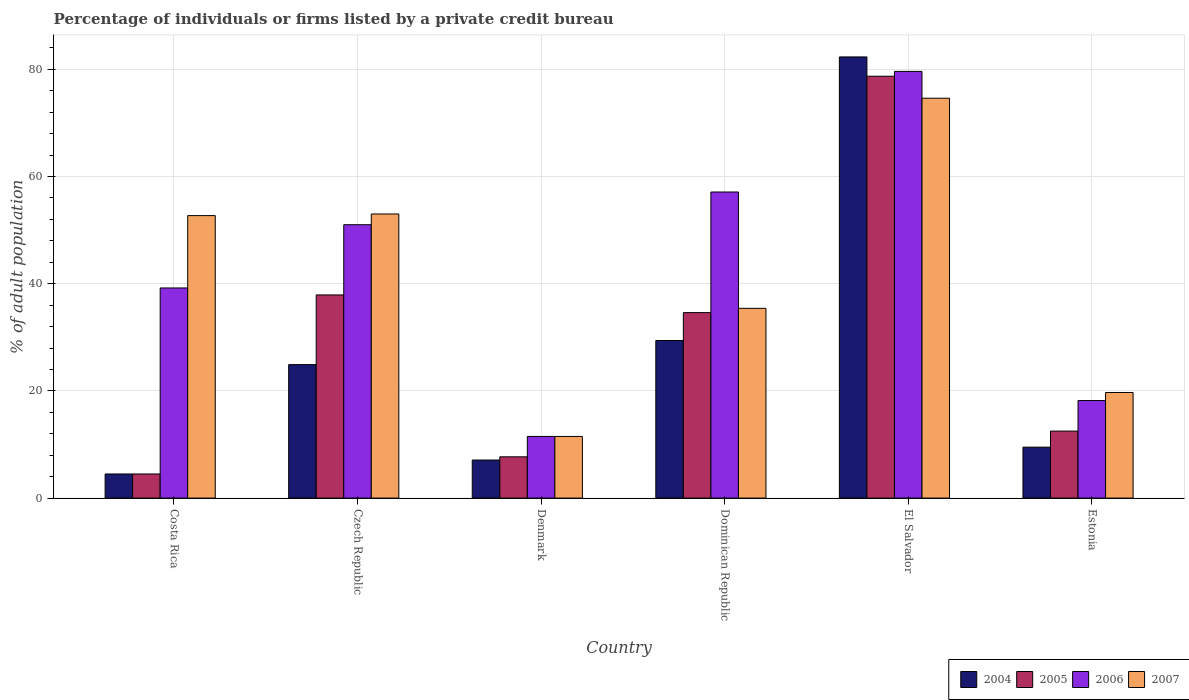How many groups of bars are there?
Offer a terse response. 6. Are the number of bars per tick equal to the number of legend labels?
Your answer should be very brief. Yes. How many bars are there on the 6th tick from the left?
Your response must be concise. 4. How many bars are there on the 6th tick from the right?
Your response must be concise. 4. What is the label of the 5th group of bars from the left?
Provide a short and direct response. El Salvador. In how many cases, is the number of bars for a given country not equal to the number of legend labels?
Make the answer very short. 0. Across all countries, what is the maximum percentage of population listed by a private credit bureau in 2004?
Provide a succinct answer. 82.3. Across all countries, what is the minimum percentage of population listed by a private credit bureau in 2005?
Your response must be concise. 4.5. In which country was the percentage of population listed by a private credit bureau in 2006 maximum?
Your answer should be very brief. El Salvador. In which country was the percentage of population listed by a private credit bureau in 2004 minimum?
Provide a short and direct response. Costa Rica. What is the total percentage of population listed by a private credit bureau in 2007 in the graph?
Make the answer very short. 246.9. What is the difference between the percentage of population listed by a private credit bureau in 2007 in Costa Rica and that in Denmark?
Give a very brief answer. 41.2. What is the difference between the percentage of population listed by a private credit bureau in 2004 in Estonia and the percentage of population listed by a private credit bureau in 2005 in Dominican Republic?
Your response must be concise. -25.1. What is the average percentage of population listed by a private credit bureau in 2006 per country?
Provide a short and direct response. 42.77. What is the difference between the percentage of population listed by a private credit bureau of/in 2007 and percentage of population listed by a private credit bureau of/in 2006 in Dominican Republic?
Offer a terse response. -21.7. In how many countries, is the percentage of population listed by a private credit bureau in 2004 greater than 32 %?
Your answer should be very brief. 1. What is the ratio of the percentage of population listed by a private credit bureau in 2007 in Czech Republic to that in Estonia?
Provide a short and direct response. 2.69. Is the percentage of population listed by a private credit bureau in 2004 in Costa Rica less than that in Dominican Republic?
Your answer should be very brief. Yes. Is the difference between the percentage of population listed by a private credit bureau in 2007 in Costa Rica and Denmark greater than the difference between the percentage of population listed by a private credit bureau in 2006 in Costa Rica and Denmark?
Offer a terse response. Yes. What is the difference between the highest and the second highest percentage of population listed by a private credit bureau in 2007?
Ensure brevity in your answer.  21.9. What is the difference between the highest and the lowest percentage of population listed by a private credit bureau in 2006?
Keep it short and to the point. 68.1. Is the sum of the percentage of population listed by a private credit bureau in 2005 in Costa Rica and El Salvador greater than the maximum percentage of population listed by a private credit bureau in 2004 across all countries?
Make the answer very short. Yes. What does the 3rd bar from the right in Dominican Republic represents?
Provide a succinct answer. 2005. Are all the bars in the graph horizontal?
Your answer should be compact. No. How many countries are there in the graph?
Give a very brief answer. 6. What is the difference between two consecutive major ticks on the Y-axis?
Your response must be concise. 20. Are the values on the major ticks of Y-axis written in scientific E-notation?
Your answer should be compact. No. What is the title of the graph?
Give a very brief answer. Percentage of individuals or firms listed by a private credit bureau. Does "1995" appear as one of the legend labels in the graph?
Your answer should be very brief. No. What is the label or title of the Y-axis?
Your answer should be very brief. % of adult population. What is the % of adult population in 2005 in Costa Rica?
Offer a very short reply. 4.5. What is the % of adult population of 2006 in Costa Rica?
Your answer should be compact. 39.2. What is the % of adult population of 2007 in Costa Rica?
Your answer should be compact. 52.7. What is the % of adult population in 2004 in Czech Republic?
Keep it short and to the point. 24.9. What is the % of adult population of 2005 in Czech Republic?
Ensure brevity in your answer.  37.9. What is the % of adult population in 2006 in Czech Republic?
Keep it short and to the point. 51. What is the % of adult population in 2007 in Czech Republic?
Offer a terse response. 53. What is the % of adult population in 2005 in Denmark?
Offer a very short reply. 7.7. What is the % of adult population in 2006 in Denmark?
Your response must be concise. 11.5. What is the % of adult population in 2004 in Dominican Republic?
Make the answer very short. 29.4. What is the % of adult population in 2005 in Dominican Republic?
Provide a short and direct response. 34.6. What is the % of adult population of 2006 in Dominican Republic?
Your answer should be compact. 57.1. What is the % of adult population of 2007 in Dominican Republic?
Ensure brevity in your answer.  35.4. What is the % of adult population of 2004 in El Salvador?
Offer a very short reply. 82.3. What is the % of adult population of 2005 in El Salvador?
Give a very brief answer. 78.7. What is the % of adult population in 2006 in El Salvador?
Provide a short and direct response. 79.6. What is the % of adult population of 2007 in El Salvador?
Make the answer very short. 74.6. What is the % of adult population in 2005 in Estonia?
Provide a short and direct response. 12.5. What is the % of adult population in 2007 in Estonia?
Offer a very short reply. 19.7. Across all countries, what is the maximum % of adult population in 2004?
Give a very brief answer. 82.3. Across all countries, what is the maximum % of adult population in 2005?
Ensure brevity in your answer.  78.7. Across all countries, what is the maximum % of adult population of 2006?
Your answer should be compact. 79.6. Across all countries, what is the maximum % of adult population of 2007?
Give a very brief answer. 74.6. Across all countries, what is the minimum % of adult population in 2004?
Keep it short and to the point. 4.5. Across all countries, what is the minimum % of adult population of 2005?
Provide a succinct answer. 4.5. Across all countries, what is the minimum % of adult population of 2006?
Your response must be concise. 11.5. Across all countries, what is the minimum % of adult population in 2007?
Offer a terse response. 11.5. What is the total % of adult population of 2004 in the graph?
Your answer should be very brief. 157.7. What is the total % of adult population of 2005 in the graph?
Keep it short and to the point. 175.9. What is the total % of adult population of 2006 in the graph?
Keep it short and to the point. 256.6. What is the total % of adult population in 2007 in the graph?
Make the answer very short. 246.9. What is the difference between the % of adult population in 2004 in Costa Rica and that in Czech Republic?
Provide a succinct answer. -20.4. What is the difference between the % of adult population of 2005 in Costa Rica and that in Czech Republic?
Your answer should be compact. -33.4. What is the difference between the % of adult population of 2004 in Costa Rica and that in Denmark?
Keep it short and to the point. -2.6. What is the difference between the % of adult population of 2006 in Costa Rica and that in Denmark?
Offer a very short reply. 27.7. What is the difference between the % of adult population in 2007 in Costa Rica and that in Denmark?
Keep it short and to the point. 41.2. What is the difference between the % of adult population in 2004 in Costa Rica and that in Dominican Republic?
Give a very brief answer. -24.9. What is the difference between the % of adult population in 2005 in Costa Rica and that in Dominican Republic?
Keep it short and to the point. -30.1. What is the difference between the % of adult population of 2006 in Costa Rica and that in Dominican Republic?
Your answer should be very brief. -17.9. What is the difference between the % of adult population of 2004 in Costa Rica and that in El Salvador?
Provide a succinct answer. -77.8. What is the difference between the % of adult population in 2005 in Costa Rica and that in El Salvador?
Your answer should be compact. -74.2. What is the difference between the % of adult population in 2006 in Costa Rica and that in El Salvador?
Keep it short and to the point. -40.4. What is the difference between the % of adult population of 2007 in Costa Rica and that in El Salvador?
Your response must be concise. -21.9. What is the difference between the % of adult population of 2004 in Costa Rica and that in Estonia?
Provide a succinct answer. -5. What is the difference between the % of adult population of 2005 in Costa Rica and that in Estonia?
Your response must be concise. -8. What is the difference between the % of adult population of 2006 in Costa Rica and that in Estonia?
Your answer should be very brief. 21. What is the difference between the % of adult population of 2007 in Costa Rica and that in Estonia?
Your answer should be compact. 33. What is the difference between the % of adult population in 2005 in Czech Republic and that in Denmark?
Make the answer very short. 30.2. What is the difference between the % of adult population of 2006 in Czech Republic and that in Denmark?
Your answer should be compact. 39.5. What is the difference between the % of adult population in 2007 in Czech Republic and that in Denmark?
Provide a succinct answer. 41.5. What is the difference between the % of adult population of 2004 in Czech Republic and that in Dominican Republic?
Give a very brief answer. -4.5. What is the difference between the % of adult population in 2005 in Czech Republic and that in Dominican Republic?
Your response must be concise. 3.3. What is the difference between the % of adult population of 2007 in Czech Republic and that in Dominican Republic?
Offer a very short reply. 17.6. What is the difference between the % of adult population of 2004 in Czech Republic and that in El Salvador?
Your response must be concise. -57.4. What is the difference between the % of adult population of 2005 in Czech Republic and that in El Salvador?
Provide a short and direct response. -40.8. What is the difference between the % of adult population in 2006 in Czech Republic and that in El Salvador?
Keep it short and to the point. -28.6. What is the difference between the % of adult population of 2007 in Czech Republic and that in El Salvador?
Ensure brevity in your answer.  -21.6. What is the difference between the % of adult population of 2004 in Czech Republic and that in Estonia?
Your answer should be compact. 15.4. What is the difference between the % of adult population of 2005 in Czech Republic and that in Estonia?
Offer a very short reply. 25.4. What is the difference between the % of adult population in 2006 in Czech Republic and that in Estonia?
Keep it short and to the point. 32.8. What is the difference between the % of adult population in 2007 in Czech Republic and that in Estonia?
Provide a short and direct response. 33.3. What is the difference between the % of adult population in 2004 in Denmark and that in Dominican Republic?
Your answer should be compact. -22.3. What is the difference between the % of adult population in 2005 in Denmark and that in Dominican Republic?
Ensure brevity in your answer.  -26.9. What is the difference between the % of adult population of 2006 in Denmark and that in Dominican Republic?
Your answer should be very brief. -45.6. What is the difference between the % of adult population in 2007 in Denmark and that in Dominican Republic?
Make the answer very short. -23.9. What is the difference between the % of adult population in 2004 in Denmark and that in El Salvador?
Offer a terse response. -75.2. What is the difference between the % of adult population of 2005 in Denmark and that in El Salvador?
Give a very brief answer. -71. What is the difference between the % of adult population of 2006 in Denmark and that in El Salvador?
Your answer should be very brief. -68.1. What is the difference between the % of adult population of 2007 in Denmark and that in El Salvador?
Your answer should be compact. -63.1. What is the difference between the % of adult population in 2004 in Denmark and that in Estonia?
Keep it short and to the point. -2.4. What is the difference between the % of adult population in 2005 in Denmark and that in Estonia?
Keep it short and to the point. -4.8. What is the difference between the % of adult population of 2007 in Denmark and that in Estonia?
Ensure brevity in your answer.  -8.2. What is the difference between the % of adult population of 2004 in Dominican Republic and that in El Salvador?
Offer a very short reply. -52.9. What is the difference between the % of adult population in 2005 in Dominican Republic and that in El Salvador?
Provide a short and direct response. -44.1. What is the difference between the % of adult population of 2006 in Dominican Republic and that in El Salvador?
Keep it short and to the point. -22.5. What is the difference between the % of adult population in 2007 in Dominican Republic and that in El Salvador?
Give a very brief answer. -39.2. What is the difference between the % of adult population of 2004 in Dominican Republic and that in Estonia?
Make the answer very short. 19.9. What is the difference between the % of adult population in 2005 in Dominican Republic and that in Estonia?
Your response must be concise. 22.1. What is the difference between the % of adult population of 2006 in Dominican Republic and that in Estonia?
Give a very brief answer. 38.9. What is the difference between the % of adult population of 2004 in El Salvador and that in Estonia?
Give a very brief answer. 72.8. What is the difference between the % of adult population of 2005 in El Salvador and that in Estonia?
Give a very brief answer. 66.2. What is the difference between the % of adult population of 2006 in El Salvador and that in Estonia?
Your response must be concise. 61.4. What is the difference between the % of adult population of 2007 in El Salvador and that in Estonia?
Give a very brief answer. 54.9. What is the difference between the % of adult population of 2004 in Costa Rica and the % of adult population of 2005 in Czech Republic?
Offer a terse response. -33.4. What is the difference between the % of adult population in 2004 in Costa Rica and the % of adult population in 2006 in Czech Republic?
Provide a short and direct response. -46.5. What is the difference between the % of adult population in 2004 in Costa Rica and the % of adult population in 2007 in Czech Republic?
Provide a short and direct response. -48.5. What is the difference between the % of adult population of 2005 in Costa Rica and the % of adult population of 2006 in Czech Republic?
Provide a succinct answer. -46.5. What is the difference between the % of adult population of 2005 in Costa Rica and the % of adult population of 2007 in Czech Republic?
Ensure brevity in your answer.  -48.5. What is the difference between the % of adult population in 2004 in Costa Rica and the % of adult population in 2005 in Denmark?
Make the answer very short. -3.2. What is the difference between the % of adult population of 2004 in Costa Rica and the % of adult population of 2006 in Denmark?
Offer a terse response. -7. What is the difference between the % of adult population of 2004 in Costa Rica and the % of adult population of 2007 in Denmark?
Provide a short and direct response. -7. What is the difference between the % of adult population in 2005 in Costa Rica and the % of adult population in 2006 in Denmark?
Your response must be concise. -7. What is the difference between the % of adult population in 2005 in Costa Rica and the % of adult population in 2007 in Denmark?
Your answer should be compact. -7. What is the difference between the % of adult population in 2006 in Costa Rica and the % of adult population in 2007 in Denmark?
Keep it short and to the point. 27.7. What is the difference between the % of adult population of 2004 in Costa Rica and the % of adult population of 2005 in Dominican Republic?
Your answer should be very brief. -30.1. What is the difference between the % of adult population in 2004 in Costa Rica and the % of adult population in 2006 in Dominican Republic?
Your response must be concise. -52.6. What is the difference between the % of adult population in 2004 in Costa Rica and the % of adult population in 2007 in Dominican Republic?
Make the answer very short. -30.9. What is the difference between the % of adult population of 2005 in Costa Rica and the % of adult population of 2006 in Dominican Republic?
Keep it short and to the point. -52.6. What is the difference between the % of adult population in 2005 in Costa Rica and the % of adult population in 2007 in Dominican Republic?
Keep it short and to the point. -30.9. What is the difference between the % of adult population of 2004 in Costa Rica and the % of adult population of 2005 in El Salvador?
Your answer should be compact. -74.2. What is the difference between the % of adult population of 2004 in Costa Rica and the % of adult population of 2006 in El Salvador?
Ensure brevity in your answer.  -75.1. What is the difference between the % of adult population in 2004 in Costa Rica and the % of adult population in 2007 in El Salvador?
Keep it short and to the point. -70.1. What is the difference between the % of adult population in 2005 in Costa Rica and the % of adult population in 2006 in El Salvador?
Keep it short and to the point. -75.1. What is the difference between the % of adult population in 2005 in Costa Rica and the % of adult population in 2007 in El Salvador?
Provide a succinct answer. -70.1. What is the difference between the % of adult population in 2006 in Costa Rica and the % of adult population in 2007 in El Salvador?
Your answer should be very brief. -35.4. What is the difference between the % of adult population of 2004 in Costa Rica and the % of adult population of 2005 in Estonia?
Give a very brief answer. -8. What is the difference between the % of adult population in 2004 in Costa Rica and the % of adult population in 2006 in Estonia?
Your response must be concise. -13.7. What is the difference between the % of adult population of 2004 in Costa Rica and the % of adult population of 2007 in Estonia?
Your answer should be very brief. -15.2. What is the difference between the % of adult population of 2005 in Costa Rica and the % of adult population of 2006 in Estonia?
Your response must be concise. -13.7. What is the difference between the % of adult population in 2005 in Costa Rica and the % of adult population in 2007 in Estonia?
Your response must be concise. -15.2. What is the difference between the % of adult population in 2004 in Czech Republic and the % of adult population in 2005 in Denmark?
Offer a terse response. 17.2. What is the difference between the % of adult population of 2004 in Czech Republic and the % of adult population of 2006 in Denmark?
Offer a very short reply. 13.4. What is the difference between the % of adult population in 2005 in Czech Republic and the % of adult population in 2006 in Denmark?
Give a very brief answer. 26.4. What is the difference between the % of adult population of 2005 in Czech Republic and the % of adult population of 2007 in Denmark?
Offer a terse response. 26.4. What is the difference between the % of adult population in 2006 in Czech Republic and the % of adult population in 2007 in Denmark?
Offer a terse response. 39.5. What is the difference between the % of adult population in 2004 in Czech Republic and the % of adult population in 2006 in Dominican Republic?
Provide a succinct answer. -32.2. What is the difference between the % of adult population of 2005 in Czech Republic and the % of adult population of 2006 in Dominican Republic?
Provide a short and direct response. -19.2. What is the difference between the % of adult population of 2005 in Czech Republic and the % of adult population of 2007 in Dominican Republic?
Your answer should be very brief. 2.5. What is the difference between the % of adult population in 2006 in Czech Republic and the % of adult population in 2007 in Dominican Republic?
Your response must be concise. 15.6. What is the difference between the % of adult population of 2004 in Czech Republic and the % of adult population of 2005 in El Salvador?
Ensure brevity in your answer.  -53.8. What is the difference between the % of adult population of 2004 in Czech Republic and the % of adult population of 2006 in El Salvador?
Offer a very short reply. -54.7. What is the difference between the % of adult population of 2004 in Czech Republic and the % of adult population of 2007 in El Salvador?
Your response must be concise. -49.7. What is the difference between the % of adult population in 2005 in Czech Republic and the % of adult population in 2006 in El Salvador?
Ensure brevity in your answer.  -41.7. What is the difference between the % of adult population in 2005 in Czech Republic and the % of adult population in 2007 in El Salvador?
Make the answer very short. -36.7. What is the difference between the % of adult population of 2006 in Czech Republic and the % of adult population of 2007 in El Salvador?
Give a very brief answer. -23.6. What is the difference between the % of adult population in 2004 in Czech Republic and the % of adult population in 2005 in Estonia?
Your answer should be very brief. 12.4. What is the difference between the % of adult population of 2004 in Czech Republic and the % of adult population of 2006 in Estonia?
Your response must be concise. 6.7. What is the difference between the % of adult population in 2004 in Czech Republic and the % of adult population in 2007 in Estonia?
Make the answer very short. 5.2. What is the difference between the % of adult population of 2005 in Czech Republic and the % of adult population of 2006 in Estonia?
Your response must be concise. 19.7. What is the difference between the % of adult population of 2006 in Czech Republic and the % of adult population of 2007 in Estonia?
Offer a terse response. 31.3. What is the difference between the % of adult population of 2004 in Denmark and the % of adult population of 2005 in Dominican Republic?
Offer a very short reply. -27.5. What is the difference between the % of adult population of 2004 in Denmark and the % of adult population of 2006 in Dominican Republic?
Offer a terse response. -50. What is the difference between the % of adult population of 2004 in Denmark and the % of adult population of 2007 in Dominican Republic?
Ensure brevity in your answer.  -28.3. What is the difference between the % of adult population of 2005 in Denmark and the % of adult population of 2006 in Dominican Republic?
Offer a very short reply. -49.4. What is the difference between the % of adult population of 2005 in Denmark and the % of adult population of 2007 in Dominican Republic?
Keep it short and to the point. -27.7. What is the difference between the % of adult population in 2006 in Denmark and the % of adult population in 2007 in Dominican Republic?
Keep it short and to the point. -23.9. What is the difference between the % of adult population in 2004 in Denmark and the % of adult population in 2005 in El Salvador?
Your response must be concise. -71.6. What is the difference between the % of adult population of 2004 in Denmark and the % of adult population of 2006 in El Salvador?
Keep it short and to the point. -72.5. What is the difference between the % of adult population in 2004 in Denmark and the % of adult population in 2007 in El Salvador?
Provide a short and direct response. -67.5. What is the difference between the % of adult population in 2005 in Denmark and the % of adult population in 2006 in El Salvador?
Your answer should be very brief. -71.9. What is the difference between the % of adult population of 2005 in Denmark and the % of adult population of 2007 in El Salvador?
Your answer should be compact. -66.9. What is the difference between the % of adult population in 2006 in Denmark and the % of adult population in 2007 in El Salvador?
Keep it short and to the point. -63.1. What is the difference between the % of adult population in 2004 in Denmark and the % of adult population in 2005 in Estonia?
Make the answer very short. -5.4. What is the difference between the % of adult population in 2004 in Denmark and the % of adult population in 2006 in Estonia?
Your answer should be very brief. -11.1. What is the difference between the % of adult population in 2004 in Denmark and the % of adult population in 2007 in Estonia?
Provide a succinct answer. -12.6. What is the difference between the % of adult population in 2005 in Denmark and the % of adult population in 2006 in Estonia?
Give a very brief answer. -10.5. What is the difference between the % of adult population in 2005 in Denmark and the % of adult population in 2007 in Estonia?
Keep it short and to the point. -12. What is the difference between the % of adult population in 2006 in Denmark and the % of adult population in 2007 in Estonia?
Offer a terse response. -8.2. What is the difference between the % of adult population of 2004 in Dominican Republic and the % of adult population of 2005 in El Salvador?
Provide a short and direct response. -49.3. What is the difference between the % of adult population in 2004 in Dominican Republic and the % of adult population in 2006 in El Salvador?
Your answer should be compact. -50.2. What is the difference between the % of adult population in 2004 in Dominican Republic and the % of adult population in 2007 in El Salvador?
Give a very brief answer. -45.2. What is the difference between the % of adult population of 2005 in Dominican Republic and the % of adult population of 2006 in El Salvador?
Your answer should be compact. -45. What is the difference between the % of adult population in 2005 in Dominican Republic and the % of adult population in 2007 in El Salvador?
Give a very brief answer. -40. What is the difference between the % of adult population of 2006 in Dominican Republic and the % of adult population of 2007 in El Salvador?
Ensure brevity in your answer.  -17.5. What is the difference between the % of adult population of 2004 in Dominican Republic and the % of adult population of 2005 in Estonia?
Provide a succinct answer. 16.9. What is the difference between the % of adult population in 2004 in Dominican Republic and the % of adult population in 2006 in Estonia?
Give a very brief answer. 11.2. What is the difference between the % of adult population of 2004 in Dominican Republic and the % of adult population of 2007 in Estonia?
Your response must be concise. 9.7. What is the difference between the % of adult population of 2005 in Dominican Republic and the % of adult population of 2006 in Estonia?
Provide a short and direct response. 16.4. What is the difference between the % of adult population of 2005 in Dominican Republic and the % of adult population of 2007 in Estonia?
Your response must be concise. 14.9. What is the difference between the % of adult population of 2006 in Dominican Republic and the % of adult population of 2007 in Estonia?
Make the answer very short. 37.4. What is the difference between the % of adult population in 2004 in El Salvador and the % of adult population in 2005 in Estonia?
Your answer should be very brief. 69.8. What is the difference between the % of adult population in 2004 in El Salvador and the % of adult population in 2006 in Estonia?
Ensure brevity in your answer.  64.1. What is the difference between the % of adult population of 2004 in El Salvador and the % of adult population of 2007 in Estonia?
Offer a very short reply. 62.6. What is the difference between the % of adult population in 2005 in El Salvador and the % of adult population in 2006 in Estonia?
Your answer should be very brief. 60.5. What is the difference between the % of adult population in 2005 in El Salvador and the % of adult population in 2007 in Estonia?
Make the answer very short. 59. What is the difference between the % of adult population in 2006 in El Salvador and the % of adult population in 2007 in Estonia?
Your answer should be compact. 59.9. What is the average % of adult population in 2004 per country?
Provide a short and direct response. 26.28. What is the average % of adult population of 2005 per country?
Your response must be concise. 29.32. What is the average % of adult population in 2006 per country?
Your answer should be compact. 42.77. What is the average % of adult population in 2007 per country?
Ensure brevity in your answer.  41.15. What is the difference between the % of adult population of 2004 and % of adult population of 2005 in Costa Rica?
Make the answer very short. 0. What is the difference between the % of adult population in 2004 and % of adult population in 2006 in Costa Rica?
Offer a very short reply. -34.7. What is the difference between the % of adult population of 2004 and % of adult population of 2007 in Costa Rica?
Ensure brevity in your answer.  -48.2. What is the difference between the % of adult population of 2005 and % of adult population of 2006 in Costa Rica?
Keep it short and to the point. -34.7. What is the difference between the % of adult population in 2005 and % of adult population in 2007 in Costa Rica?
Offer a terse response. -48.2. What is the difference between the % of adult population of 2004 and % of adult population of 2006 in Czech Republic?
Your response must be concise. -26.1. What is the difference between the % of adult population of 2004 and % of adult population of 2007 in Czech Republic?
Your response must be concise. -28.1. What is the difference between the % of adult population in 2005 and % of adult population in 2007 in Czech Republic?
Your answer should be compact. -15.1. What is the difference between the % of adult population of 2004 and % of adult population of 2005 in Denmark?
Your answer should be compact. -0.6. What is the difference between the % of adult population in 2005 and % of adult population in 2007 in Denmark?
Your answer should be very brief. -3.8. What is the difference between the % of adult population of 2004 and % of adult population of 2006 in Dominican Republic?
Ensure brevity in your answer.  -27.7. What is the difference between the % of adult population in 2005 and % of adult population in 2006 in Dominican Republic?
Provide a short and direct response. -22.5. What is the difference between the % of adult population in 2005 and % of adult population in 2007 in Dominican Republic?
Give a very brief answer. -0.8. What is the difference between the % of adult population in 2006 and % of adult population in 2007 in Dominican Republic?
Ensure brevity in your answer.  21.7. What is the difference between the % of adult population in 2004 and % of adult population in 2005 in El Salvador?
Offer a very short reply. 3.6. What is the difference between the % of adult population in 2004 and % of adult population in 2006 in El Salvador?
Your answer should be compact. 2.7. What is the difference between the % of adult population in 2005 and % of adult population in 2006 in El Salvador?
Ensure brevity in your answer.  -0.9. What is the difference between the % of adult population of 2005 and % of adult population of 2007 in El Salvador?
Keep it short and to the point. 4.1. What is the difference between the % of adult population of 2006 and % of adult population of 2007 in El Salvador?
Make the answer very short. 5. What is the difference between the % of adult population of 2005 and % of adult population of 2006 in Estonia?
Keep it short and to the point. -5.7. What is the ratio of the % of adult population in 2004 in Costa Rica to that in Czech Republic?
Offer a terse response. 0.18. What is the ratio of the % of adult population in 2005 in Costa Rica to that in Czech Republic?
Your response must be concise. 0.12. What is the ratio of the % of adult population in 2006 in Costa Rica to that in Czech Republic?
Ensure brevity in your answer.  0.77. What is the ratio of the % of adult population in 2007 in Costa Rica to that in Czech Republic?
Provide a short and direct response. 0.99. What is the ratio of the % of adult population in 2004 in Costa Rica to that in Denmark?
Your answer should be compact. 0.63. What is the ratio of the % of adult population in 2005 in Costa Rica to that in Denmark?
Your answer should be very brief. 0.58. What is the ratio of the % of adult population in 2006 in Costa Rica to that in Denmark?
Ensure brevity in your answer.  3.41. What is the ratio of the % of adult population in 2007 in Costa Rica to that in Denmark?
Your response must be concise. 4.58. What is the ratio of the % of adult population of 2004 in Costa Rica to that in Dominican Republic?
Make the answer very short. 0.15. What is the ratio of the % of adult population of 2005 in Costa Rica to that in Dominican Republic?
Ensure brevity in your answer.  0.13. What is the ratio of the % of adult population of 2006 in Costa Rica to that in Dominican Republic?
Provide a succinct answer. 0.69. What is the ratio of the % of adult population in 2007 in Costa Rica to that in Dominican Republic?
Keep it short and to the point. 1.49. What is the ratio of the % of adult population in 2004 in Costa Rica to that in El Salvador?
Your answer should be very brief. 0.05. What is the ratio of the % of adult population of 2005 in Costa Rica to that in El Salvador?
Provide a succinct answer. 0.06. What is the ratio of the % of adult population in 2006 in Costa Rica to that in El Salvador?
Make the answer very short. 0.49. What is the ratio of the % of adult population in 2007 in Costa Rica to that in El Salvador?
Give a very brief answer. 0.71. What is the ratio of the % of adult population of 2004 in Costa Rica to that in Estonia?
Provide a succinct answer. 0.47. What is the ratio of the % of adult population of 2005 in Costa Rica to that in Estonia?
Your answer should be compact. 0.36. What is the ratio of the % of adult population of 2006 in Costa Rica to that in Estonia?
Provide a short and direct response. 2.15. What is the ratio of the % of adult population in 2007 in Costa Rica to that in Estonia?
Provide a short and direct response. 2.68. What is the ratio of the % of adult population in 2004 in Czech Republic to that in Denmark?
Provide a short and direct response. 3.51. What is the ratio of the % of adult population in 2005 in Czech Republic to that in Denmark?
Offer a very short reply. 4.92. What is the ratio of the % of adult population of 2006 in Czech Republic to that in Denmark?
Offer a very short reply. 4.43. What is the ratio of the % of adult population of 2007 in Czech Republic to that in Denmark?
Your response must be concise. 4.61. What is the ratio of the % of adult population of 2004 in Czech Republic to that in Dominican Republic?
Give a very brief answer. 0.85. What is the ratio of the % of adult population of 2005 in Czech Republic to that in Dominican Republic?
Make the answer very short. 1.1. What is the ratio of the % of adult population in 2006 in Czech Republic to that in Dominican Republic?
Give a very brief answer. 0.89. What is the ratio of the % of adult population in 2007 in Czech Republic to that in Dominican Republic?
Give a very brief answer. 1.5. What is the ratio of the % of adult population of 2004 in Czech Republic to that in El Salvador?
Your answer should be compact. 0.3. What is the ratio of the % of adult population of 2005 in Czech Republic to that in El Salvador?
Provide a succinct answer. 0.48. What is the ratio of the % of adult population of 2006 in Czech Republic to that in El Salvador?
Your answer should be compact. 0.64. What is the ratio of the % of adult population of 2007 in Czech Republic to that in El Salvador?
Offer a terse response. 0.71. What is the ratio of the % of adult population of 2004 in Czech Republic to that in Estonia?
Your answer should be very brief. 2.62. What is the ratio of the % of adult population of 2005 in Czech Republic to that in Estonia?
Make the answer very short. 3.03. What is the ratio of the % of adult population of 2006 in Czech Republic to that in Estonia?
Provide a succinct answer. 2.8. What is the ratio of the % of adult population of 2007 in Czech Republic to that in Estonia?
Provide a short and direct response. 2.69. What is the ratio of the % of adult population in 2004 in Denmark to that in Dominican Republic?
Keep it short and to the point. 0.24. What is the ratio of the % of adult population in 2005 in Denmark to that in Dominican Republic?
Ensure brevity in your answer.  0.22. What is the ratio of the % of adult population in 2006 in Denmark to that in Dominican Republic?
Your answer should be compact. 0.2. What is the ratio of the % of adult population of 2007 in Denmark to that in Dominican Republic?
Keep it short and to the point. 0.32. What is the ratio of the % of adult population in 2004 in Denmark to that in El Salvador?
Your response must be concise. 0.09. What is the ratio of the % of adult population in 2005 in Denmark to that in El Salvador?
Provide a short and direct response. 0.1. What is the ratio of the % of adult population in 2006 in Denmark to that in El Salvador?
Give a very brief answer. 0.14. What is the ratio of the % of adult population in 2007 in Denmark to that in El Salvador?
Your answer should be very brief. 0.15. What is the ratio of the % of adult population of 2004 in Denmark to that in Estonia?
Keep it short and to the point. 0.75. What is the ratio of the % of adult population of 2005 in Denmark to that in Estonia?
Ensure brevity in your answer.  0.62. What is the ratio of the % of adult population of 2006 in Denmark to that in Estonia?
Provide a short and direct response. 0.63. What is the ratio of the % of adult population in 2007 in Denmark to that in Estonia?
Your answer should be very brief. 0.58. What is the ratio of the % of adult population of 2004 in Dominican Republic to that in El Salvador?
Ensure brevity in your answer.  0.36. What is the ratio of the % of adult population in 2005 in Dominican Republic to that in El Salvador?
Give a very brief answer. 0.44. What is the ratio of the % of adult population in 2006 in Dominican Republic to that in El Salvador?
Provide a short and direct response. 0.72. What is the ratio of the % of adult population of 2007 in Dominican Republic to that in El Salvador?
Provide a short and direct response. 0.47. What is the ratio of the % of adult population in 2004 in Dominican Republic to that in Estonia?
Your answer should be compact. 3.09. What is the ratio of the % of adult population of 2005 in Dominican Republic to that in Estonia?
Provide a succinct answer. 2.77. What is the ratio of the % of adult population of 2006 in Dominican Republic to that in Estonia?
Ensure brevity in your answer.  3.14. What is the ratio of the % of adult population of 2007 in Dominican Republic to that in Estonia?
Make the answer very short. 1.8. What is the ratio of the % of adult population in 2004 in El Salvador to that in Estonia?
Make the answer very short. 8.66. What is the ratio of the % of adult population in 2005 in El Salvador to that in Estonia?
Ensure brevity in your answer.  6.3. What is the ratio of the % of adult population in 2006 in El Salvador to that in Estonia?
Give a very brief answer. 4.37. What is the ratio of the % of adult population in 2007 in El Salvador to that in Estonia?
Keep it short and to the point. 3.79. What is the difference between the highest and the second highest % of adult population in 2004?
Ensure brevity in your answer.  52.9. What is the difference between the highest and the second highest % of adult population of 2005?
Ensure brevity in your answer.  40.8. What is the difference between the highest and the second highest % of adult population of 2006?
Your response must be concise. 22.5. What is the difference between the highest and the second highest % of adult population of 2007?
Provide a short and direct response. 21.6. What is the difference between the highest and the lowest % of adult population in 2004?
Offer a very short reply. 77.8. What is the difference between the highest and the lowest % of adult population in 2005?
Offer a terse response. 74.2. What is the difference between the highest and the lowest % of adult population of 2006?
Give a very brief answer. 68.1. What is the difference between the highest and the lowest % of adult population in 2007?
Your answer should be compact. 63.1. 